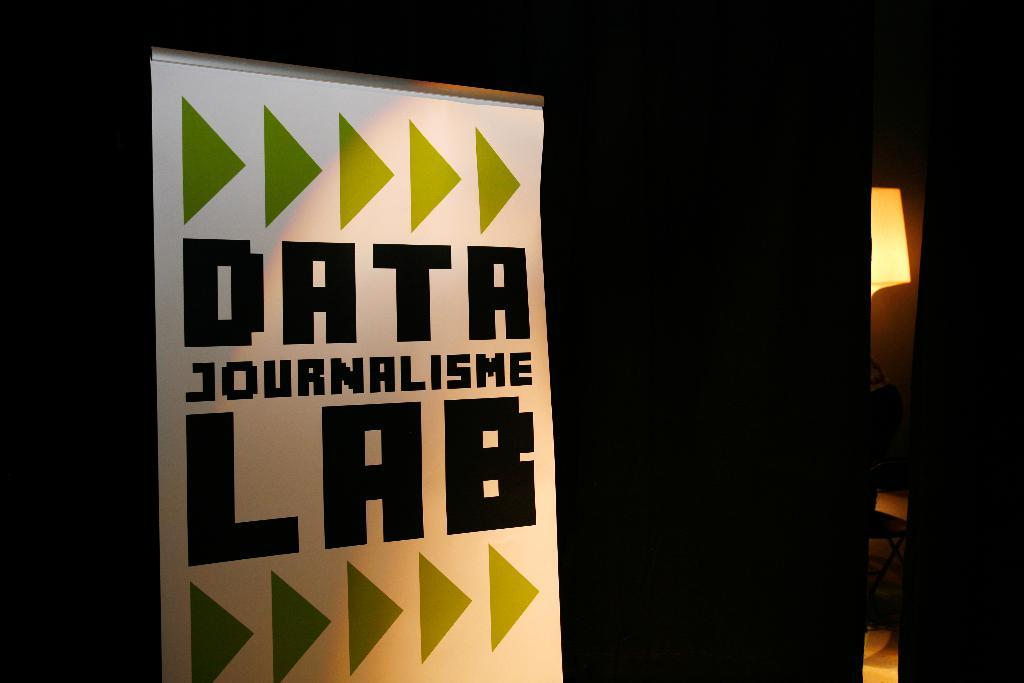<image>
Describe the image concisely. White sign on a black wall that says "Data Journalisme Lab". 